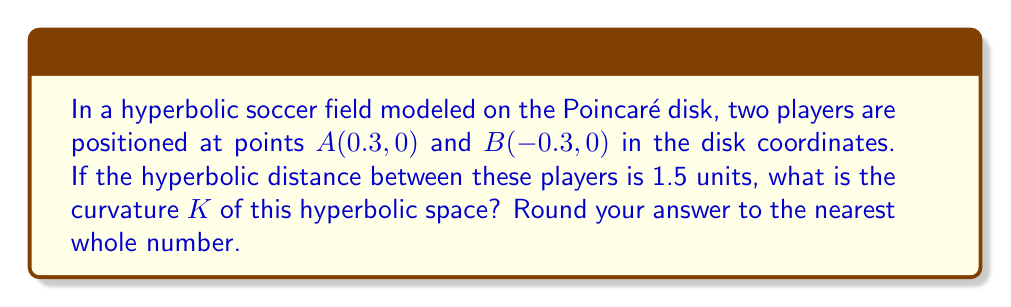What is the answer to this math problem? Let's approach this step-by-step:

1) In the Poincaré disk model, the hyperbolic distance d between two points $(x_1, y_1)$ and $(x_2, y_2)$ is given by:

   $$d = 2 \tanh^{-1}\left(\frac{\sqrt{(x_2-x_1)^2 + (y_2-y_1)^2}}{\sqrt{(1-x_1^2-y_1^2)(1-x_2^2-y_2^2) + (x_2-x_1)^2 + (y_2-y_1)^2}}\right)$$

2) In our case, $(x_1, y_1) = (0.3, 0)$ and $(x_2, y_2) = (-0.3, 0)$. Let's substitute these:

   $$1.5 = 2 \tanh^{-1}\left(\frac{\sqrt{(-0.3-0.3)^2 + (0-0)^2}}{\sqrt{(1-0.3^2-0^2)(1-(-0.3)^2-0^2) + (-0.3-0.3)^2 + (0-0)^2}}\right)$$

3) Simplify:

   $$1.5 = 2 \tanh^{-1}\left(\frac{\sqrt{0.6^2}}{\sqrt{(1-0.09)(1-0.09) + 0.6^2}}\right)$$

   $$1.5 = 2 \tanh^{-1}\left(\frac{0.6}{\sqrt{0.91^2 + 0.36}}\right)$$

   $$1.5 = 2 \tanh^{-1}\left(\frac{0.6}{\sqrt{1.1881}}\right)$$

   $$1.5 = 2 \tanh^{-1}\left(\frac{0.6}{1.09})\right)$$

4) Now, let's solve for the curvature K. In hyperbolic geometry, the curvature K is related to the hyperbolic distance d by:

   $$d = \frac{2}{\sqrt{-K}} \tanh^{-1}\left(\frac{0.6}{1.09}\right)$$

5) Substitute our known values:

   $$1.5 = \frac{2}{\sqrt{-K}} \tanh^{-1}\left(\frac{0.6}{1.09}\right)$$

6) Solve for K:

   $$\sqrt{-K} = \frac{2}{1.5} \tanh^{-1}\left(\frac{0.6}{1.09}\right)$$

   $$K = -\left(\frac{2}{1.5} \tanh^{-1}\left(\frac{0.6}{1.09}\right)\right)^2$$

7) Calculate the value (you can use a calculator for this):

   $$K \approx -2.8416$$

8) Rounding to the nearest whole number:

   $$K \approx -3$$
Answer: $-3$ 